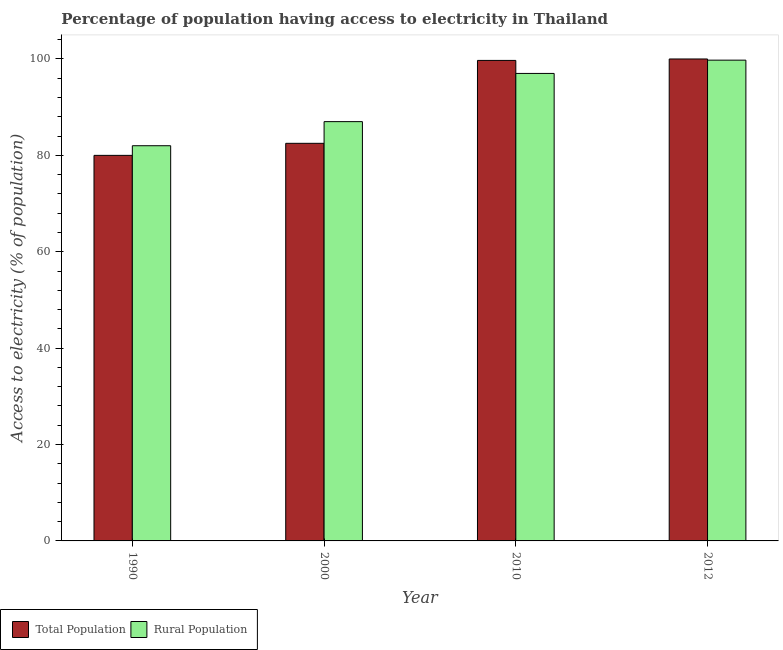How many different coloured bars are there?
Your response must be concise. 2. How many bars are there on the 1st tick from the left?
Ensure brevity in your answer.  2. How many bars are there on the 3rd tick from the right?
Your answer should be very brief. 2. In how many cases, is the number of bars for a given year not equal to the number of legend labels?
Your answer should be compact. 0. Across all years, what is the maximum percentage of population having access to electricity?
Offer a very short reply. 100. Across all years, what is the minimum percentage of population having access to electricity?
Your response must be concise. 80. In which year was the percentage of rural population having access to electricity maximum?
Ensure brevity in your answer.  2012. What is the total percentage of population having access to electricity in the graph?
Provide a short and direct response. 362.2. What is the difference between the percentage of population having access to electricity in 1990 and that in 2010?
Your answer should be compact. -19.7. What is the difference between the percentage of population having access to electricity in 2000 and the percentage of rural population having access to electricity in 2012?
Keep it short and to the point. -17.5. What is the average percentage of population having access to electricity per year?
Make the answer very short. 90.55. What is the ratio of the percentage of population having access to electricity in 2000 to that in 2012?
Offer a terse response. 0.82. Is the percentage of population having access to electricity in 2000 less than that in 2010?
Make the answer very short. Yes. Is the difference between the percentage of rural population having access to electricity in 1990 and 2012 greater than the difference between the percentage of population having access to electricity in 1990 and 2012?
Your answer should be very brief. No. What is the difference between the highest and the second highest percentage of population having access to electricity?
Make the answer very short. 0.3. What is the difference between the highest and the lowest percentage of population having access to electricity?
Keep it short and to the point. 20. In how many years, is the percentage of rural population having access to electricity greater than the average percentage of rural population having access to electricity taken over all years?
Your answer should be compact. 2. What does the 1st bar from the left in 2012 represents?
Your answer should be compact. Total Population. What does the 1st bar from the right in 2010 represents?
Keep it short and to the point. Rural Population. How many bars are there?
Keep it short and to the point. 8. Are all the bars in the graph horizontal?
Offer a terse response. No. What is the difference between two consecutive major ticks on the Y-axis?
Give a very brief answer. 20. Are the values on the major ticks of Y-axis written in scientific E-notation?
Provide a succinct answer. No. Where does the legend appear in the graph?
Offer a very short reply. Bottom left. What is the title of the graph?
Provide a short and direct response. Percentage of population having access to electricity in Thailand. Does "Export" appear as one of the legend labels in the graph?
Give a very brief answer. No. What is the label or title of the X-axis?
Make the answer very short. Year. What is the label or title of the Y-axis?
Offer a very short reply. Access to electricity (% of population). What is the Access to electricity (% of population) in Total Population in 1990?
Your answer should be very brief. 80. What is the Access to electricity (% of population) in Rural Population in 1990?
Make the answer very short. 82. What is the Access to electricity (% of population) in Total Population in 2000?
Provide a succinct answer. 82.5. What is the Access to electricity (% of population) of Total Population in 2010?
Your response must be concise. 99.7. What is the Access to electricity (% of population) in Rural Population in 2010?
Provide a short and direct response. 97. What is the Access to electricity (% of population) in Total Population in 2012?
Your answer should be compact. 100. What is the Access to electricity (% of population) of Rural Population in 2012?
Your answer should be compact. 99.75. Across all years, what is the maximum Access to electricity (% of population) of Rural Population?
Give a very brief answer. 99.75. Across all years, what is the minimum Access to electricity (% of population) of Rural Population?
Your answer should be very brief. 82. What is the total Access to electricity (% of population) of Total Population in the graph?
Provide a short and direct response. 362.2. What is the total Access to electricity (% of population) in Rural Population in the graph?
Make the answer very short. 365.75. What is the difference between the Access to electricity (% of population) in Total Population in 1990 and that in 2010?
Provide a succinct answer. -19.7. What is the difference between the Access to electricity (% of population) of Total Population in 1990 and that in 2012?
Provide a succinct answer. -20. What is the difference between the Access to electricity (% of population) of Rural Population in 1990 and that in 2012?
Your answer should be very brief. -17.75. What is the difference between the Access to electricity (% of population) of Total Population in 2000 and that in 2010?
Provide a succinct answer. -17.2. What is the difference between the Access to electricity (% of population) of Rural Population in 2000 and that in 2010?
Offer a very short reply. -10. What is the difference between the Access to electricity (% of population) in Total Population in 2000 and that in 2012?
Offer a terse response. -17.5. What is the difference between the Access to electricity (% of population) of Rural Population in 2000 and that in 2012?
Make the answer very short. -12.75. What is the difference between the Access to electricity (% of population) in Rural Population in 2010 and that in 2012?
Offer a very short reply. -2.75. What is the difference between the Access to electricity (% of population) in Total Population in 1990 and the Access to electricity (% of population) in Rural Population in 2012?
Make the answer very short. -19.75. What is the difference between the Access to electricity (% of population) of Total Population in 2000 and the Access to electricity (% of population) of Rural Population in 2010?
Give a very brief answer. -14.5. What is the difference between the Access to electricity (% of population) of Total Population in 2000 and the Access to electricity (% of population) of Rural Population in 2012?
Your answer should be compact. -17.25. What is the difference between the Access to electricity (% of population) of Total Population in 2010 and the Access to electricity (% of population) of Rural Population in 2012?
Keep it short and to the point. -0.05. What is the average Access to electricity (% of population) of Total Population per year?
Ensure brevity in your answer.  90.55. What is the average Access to electricity (% of population) of Rural Population per year?
Ensure brevity in your answer.  91.44. In the year 2012, what is the difference between the Access to electricity (% of population) in Total Population and Access to electricity (% of population) in Rural Population?
Provide a succinct answer. 0.25. What is the ratio of the Access to electricity (% of population) in Total Population in 1990 to that in 2000?
Your response must be concise. 0.97. What is the ratio of the Access to electricity (% of population) of Rural Population in 1990 to that in 2000?
Offer a terse response. 0.94. What is the ratio of the Access to electricity (% of population) of Total Population in 1990 to that in 2010?
Provide a short and direct response. 0.8. What is the ratio of the Access to electricity (% of population) of Rural Population in 1990 to that in 2010?
Keep it short and to the point. 0.85. What is the ratio of the Access to electricity (% of population) of Rural Population in 1990 to that in 2012?
Provide a succinct answer. 0.82. What is the ratio of the Access to electricity (% of population) in Total Population in 2000 to that in 2010?
Provide a succinct answer. 0.83. What is the ratio of the Access to electricity (% of population) in Rural Population in 2000 to that in 2010?
Your answer should be very brief. 0.9. What is the ratio of the Access to electricity (% of population) in Total Population in 2000 to that in 2012?
Make the answer very short. 0.82. What is the ratio of the Access to electricity (% of population) in Rural Population in 2000 to that in 2012?
Your answer should be very brief. 0.87. What is the ratio of the Access to electricity (% of population) of Rural Population in 2010 to that in 2012?
Your answer should be compact. 0.97. What is the difference between the highest and the second highest Access to electricity (% of population) of Rural Population?
Your response must be concise. 2.75. What is the difference between the highest and the lowest Access to electricity (% of population) in Total Population?
Your response must be concise. 20. What is the difference between the highest and the lowest Access to electricity (% of population) of Rural Population?
Provide a succinct answer. 17.75. 